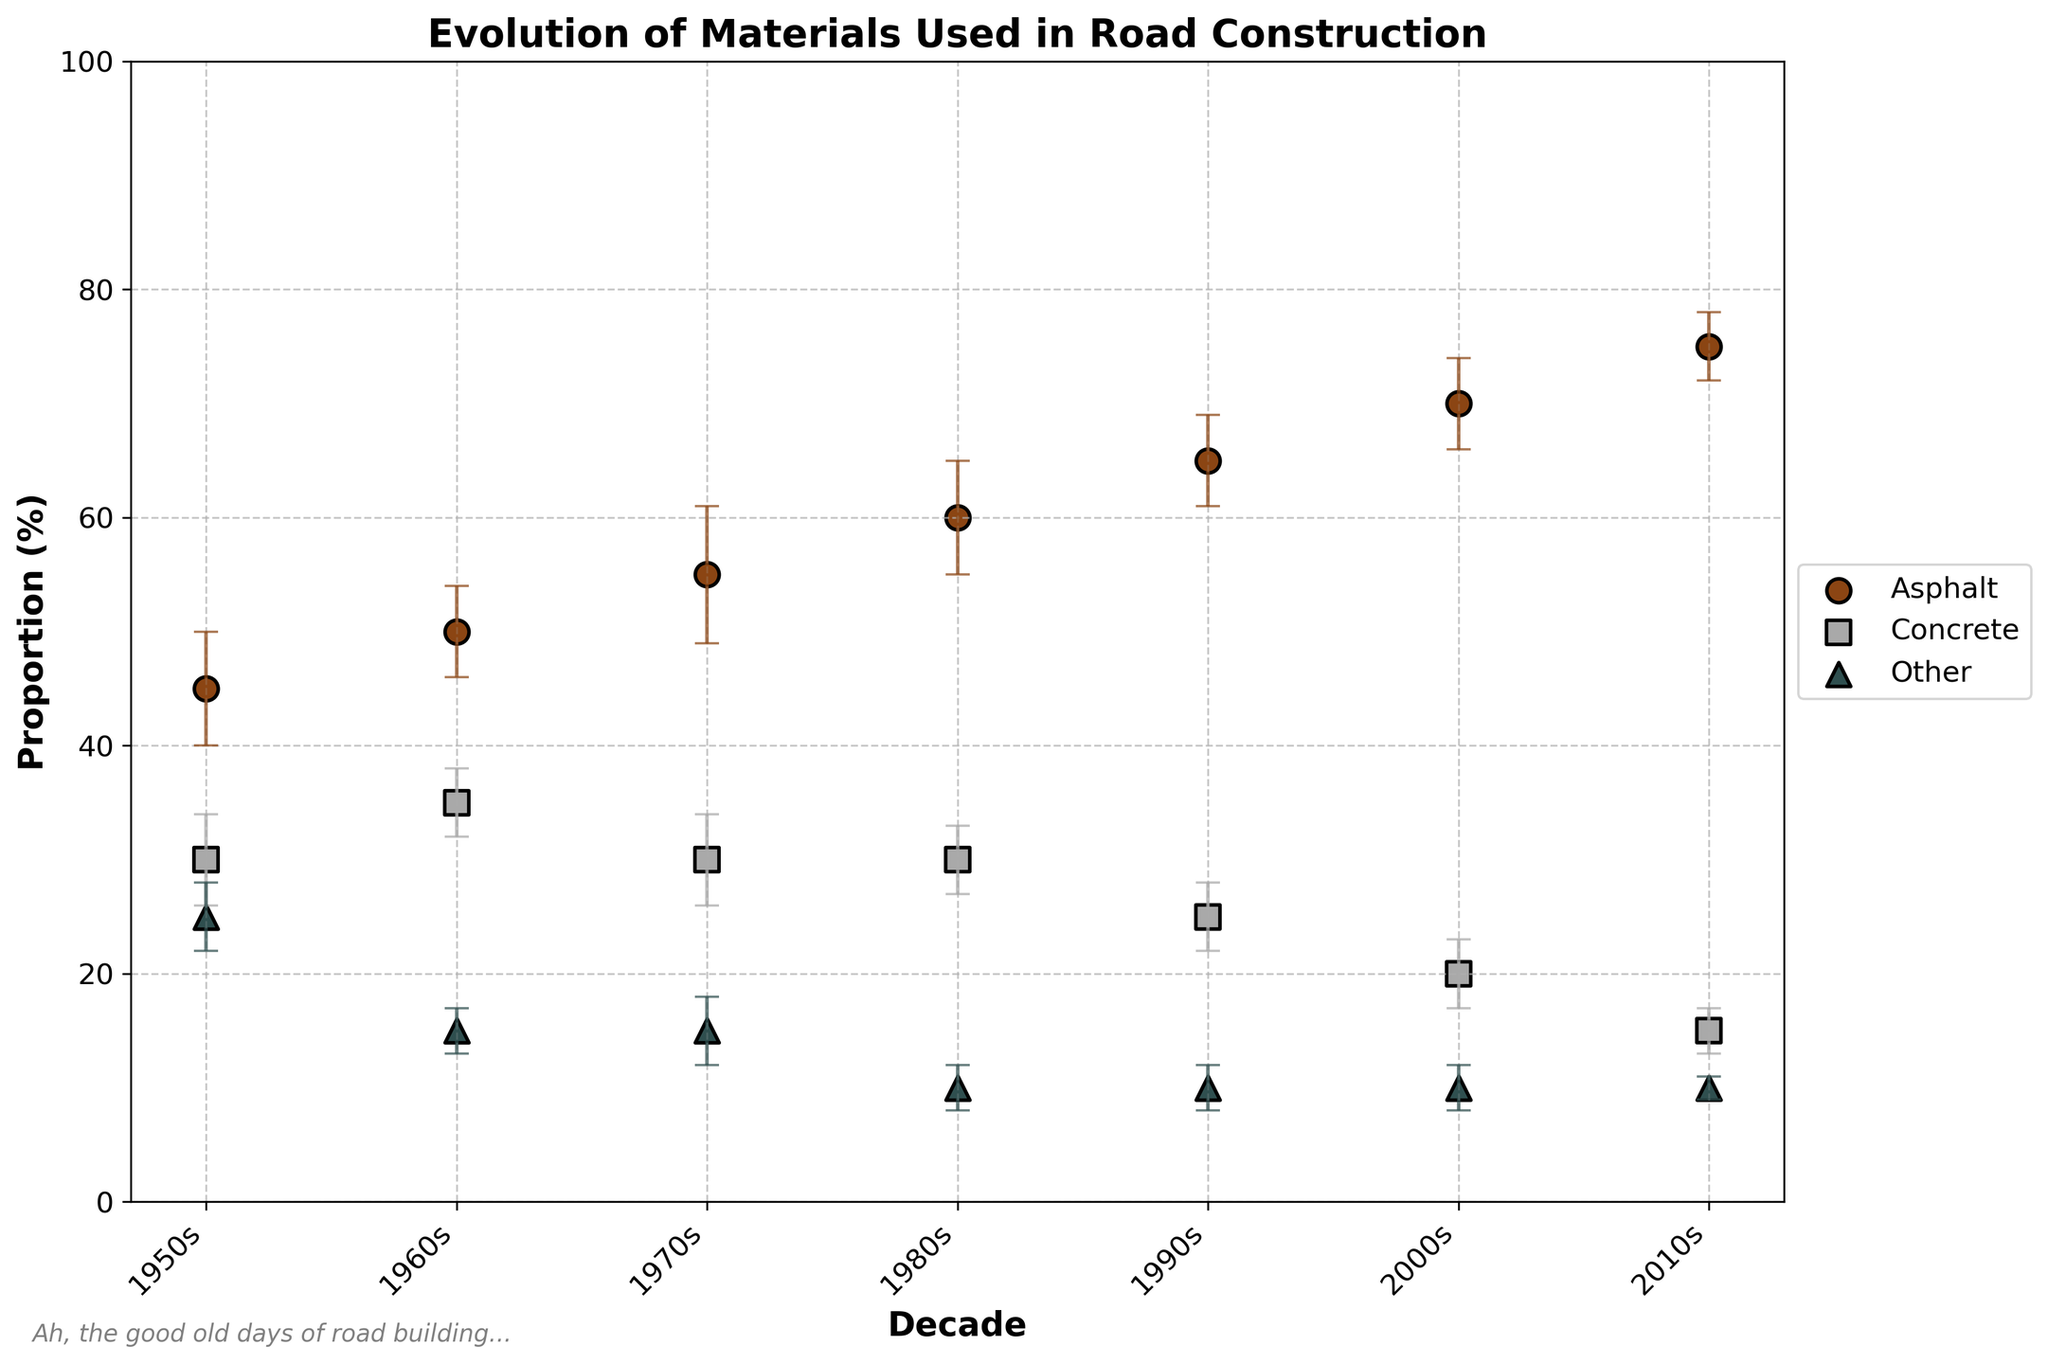What is the title of the plot? The title of the plot is displayed at the top of the plot, stating "Evolution of Materials Used in Road Construction".
Answer: Evolution of Materials Used in Road Construction Which material had the highest proportion in the 2010s? The material proportions for the 2010s can be identified by looking at the y-values corresponding to the 2010s on the x-axis. Asphalt has the highest proportion at 75%.
Answer: Asphalt How did the proportion of concrete change from the 1950s to the 2010s? To find this, compare the y-values for concrete in the 1950s and 2010s. The proportion went from 30% in the 1950s to 15% in the 2010s.
Answer: Decreased Which decade had the smallest error bar for "Other" materials? The error bars for "Other" materials can be compared across decades. The 2010s show the smallest error bar for "Other".
Answer: 2010s What was the general trend in the proportion of asphalt used over the decades? By looking at the scatter points for asphalt across decades, it can be seen that the proportion of asphalt has increased steadily from 45% in the 1950s to 75% in the 2010s.
Answer: Increased Compare the error margins for concrete and other materials in the 1960s. Examine the length of error bars for concrete and other in the 1960s. Concrete has an error of 3%, while Other has an error of 2%. Concrete's error margin is larger.
Answer: Concrete's error margin is larger Between which decades did asphalt show the greatest increase in proportion? Check for the largest difference in the y-values for asphalt between consecutive decades. The greatest increase is from the 2000s (70%) to the 2010s (75%), an increase of 5%.
Answer: 2000s to 2010s What is the primary color used to represent Asphalt in the plot? The color representing Asphalt can be identified directly by looking at the legend. Asphalt is represented by the brown color.
Answer: Brown What were the proportions of "Other" materials in the 1970s and 1980s, and what is their difference? Locate the points for "Other" in the 1970s (15%) and 1980s (10%). The difference is 15% - 10% = 5%.
Answer: 5% What relation can be observed between asphalt and concrete proportions over time? By examining trends of both materials, it is clear that as the proportion of asphalt increases, the proportion of concrete decreases over time.
Answer: Inverse relationship 